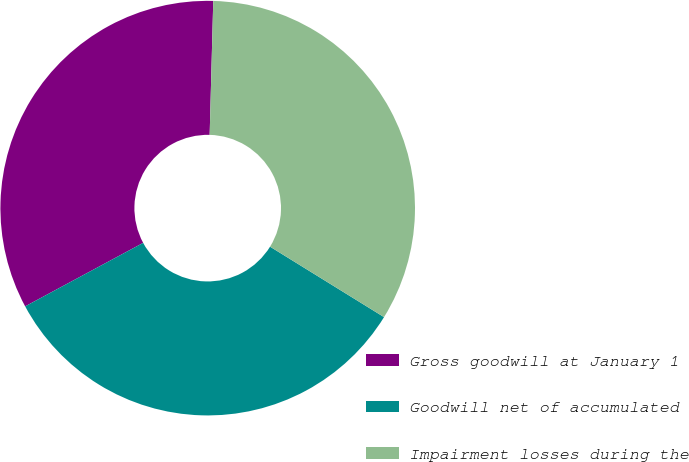<chart> <loc_0><loc_0><loc_500><loc_500><pie_chart><fcel>Gross goodwill at January 1<fcel>Goodwill net of accumulated<fcel>Impairment losses during the<nl><fcel>33.28%<fcel>33.33%<fcel>33.38%<nl></chart> 